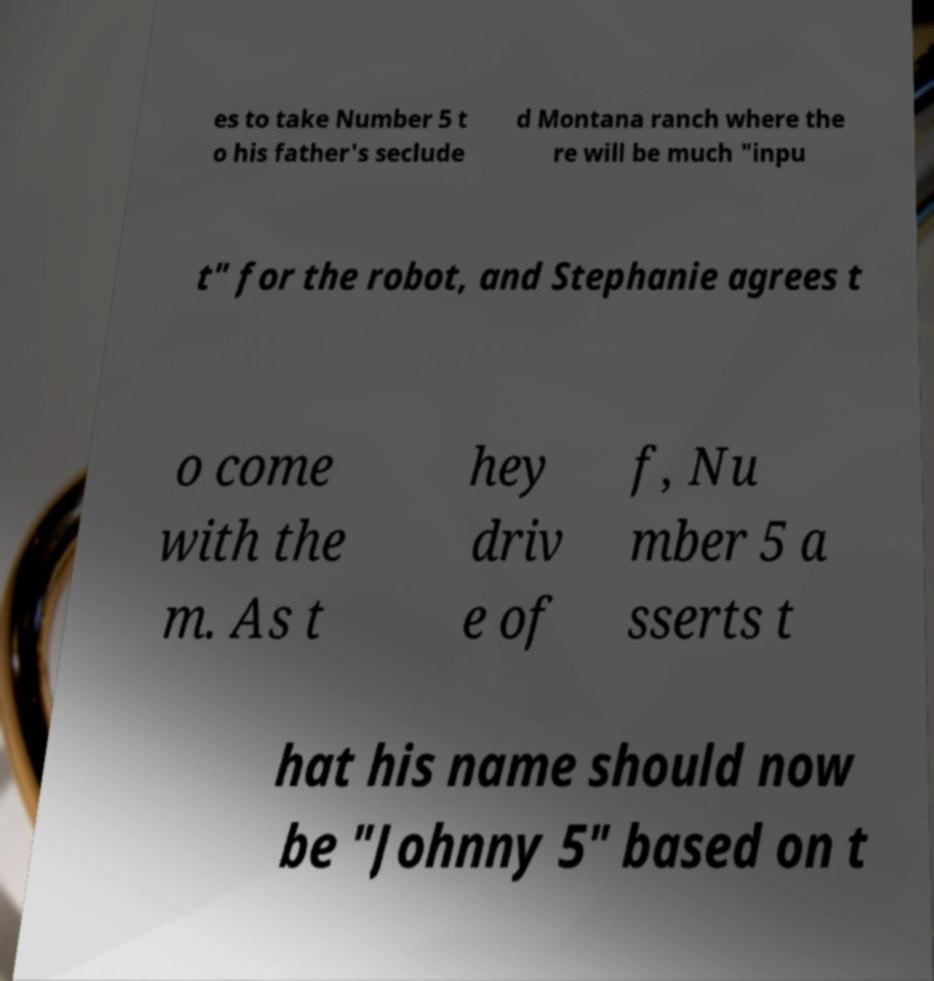Please identify and transcribe the text found in this image. es to take Number 5 t o his father's seclude d Montana ranch where the re will be much "inpu t" for the robot, and Stephanie agrees t o come with the m. As t hey driv e of f, Nu mber 5 a sserts t hat his name should now be "Johnny 5" based on t 